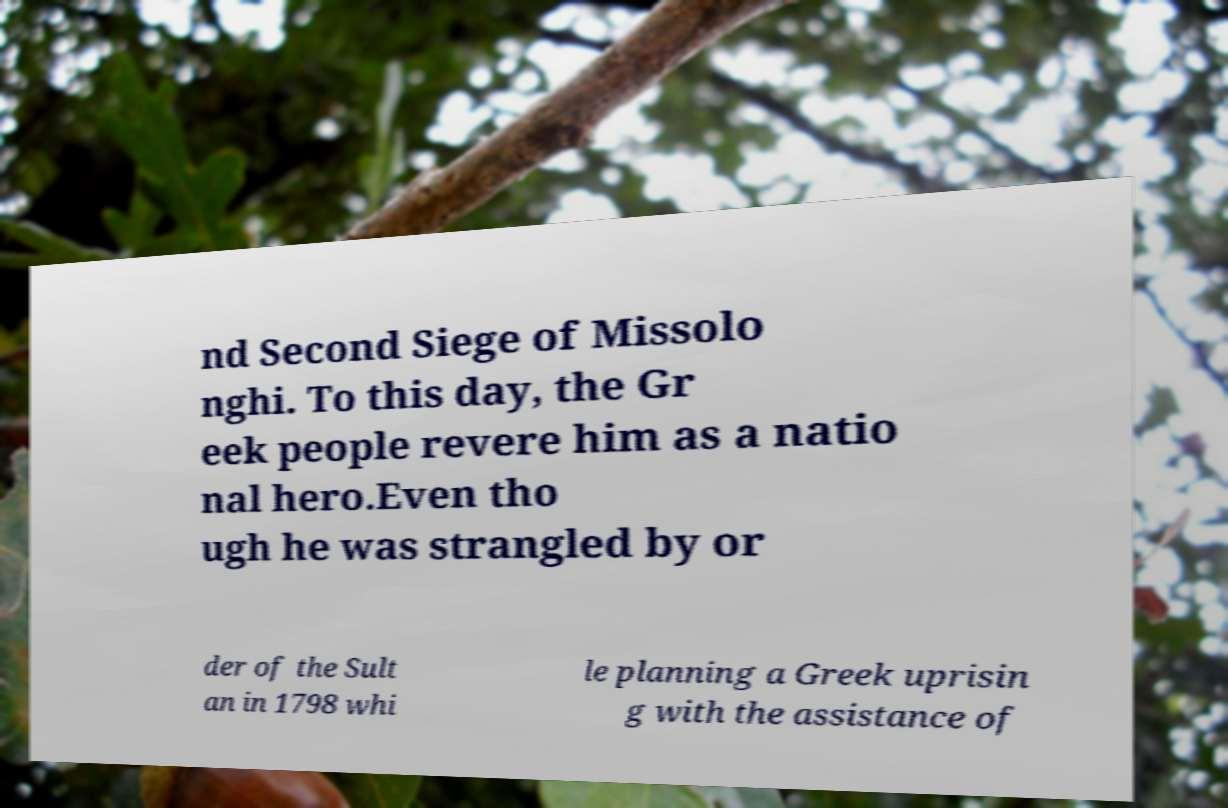Could you extract and type out the text from this image? nd Second Siege of Missolo nghi. To this day, the Gr eek people revere him as a natio nal hero.Even tho ugh he was strangled by or der of the Sult an in 1798 whi le planning a Greek uprisin g with the assistance of 